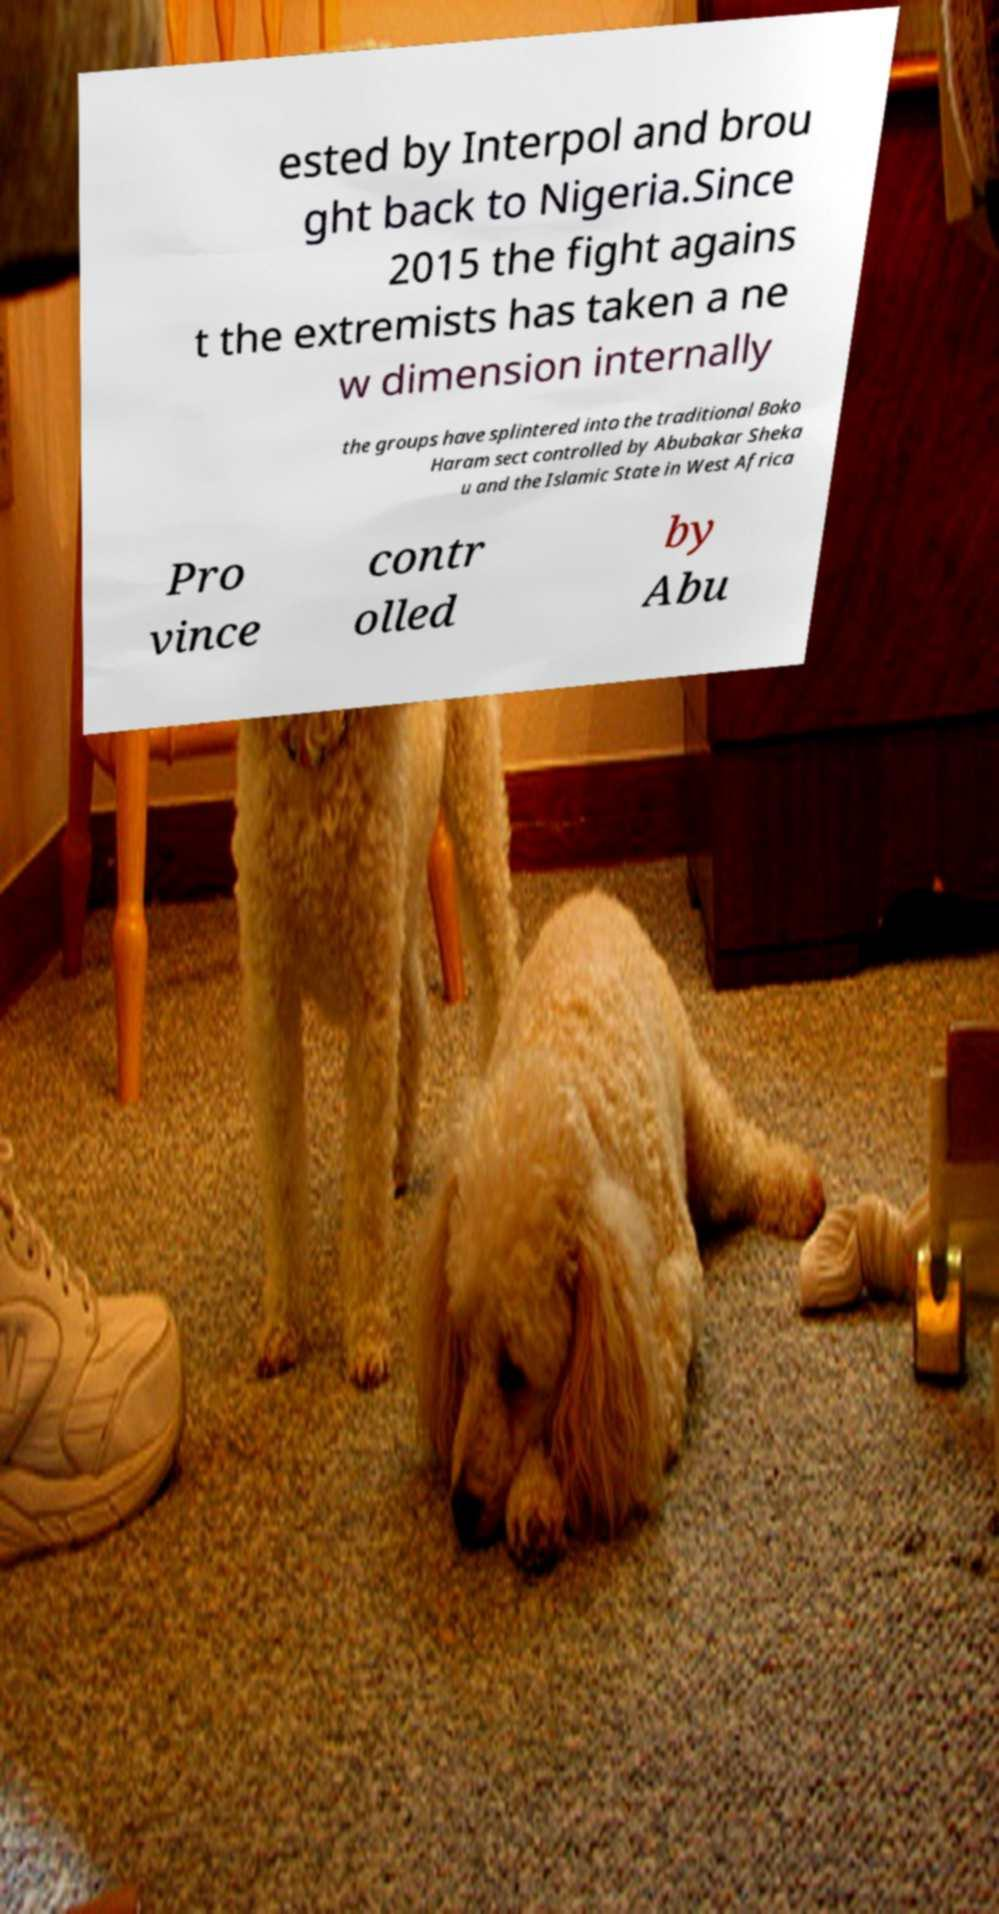Can you accurately transcribe the text from the provided image for me? ested by Interpol and brou ght back to Nigeria.Since 2015 the fight agains t the extremists has taken a ne w dimension internally the groups have splintered into the traditional Boko Haram sect controlled by Abubakar Sheka u and the Islamic State in West Africa Pro vince contr olled by Abu 